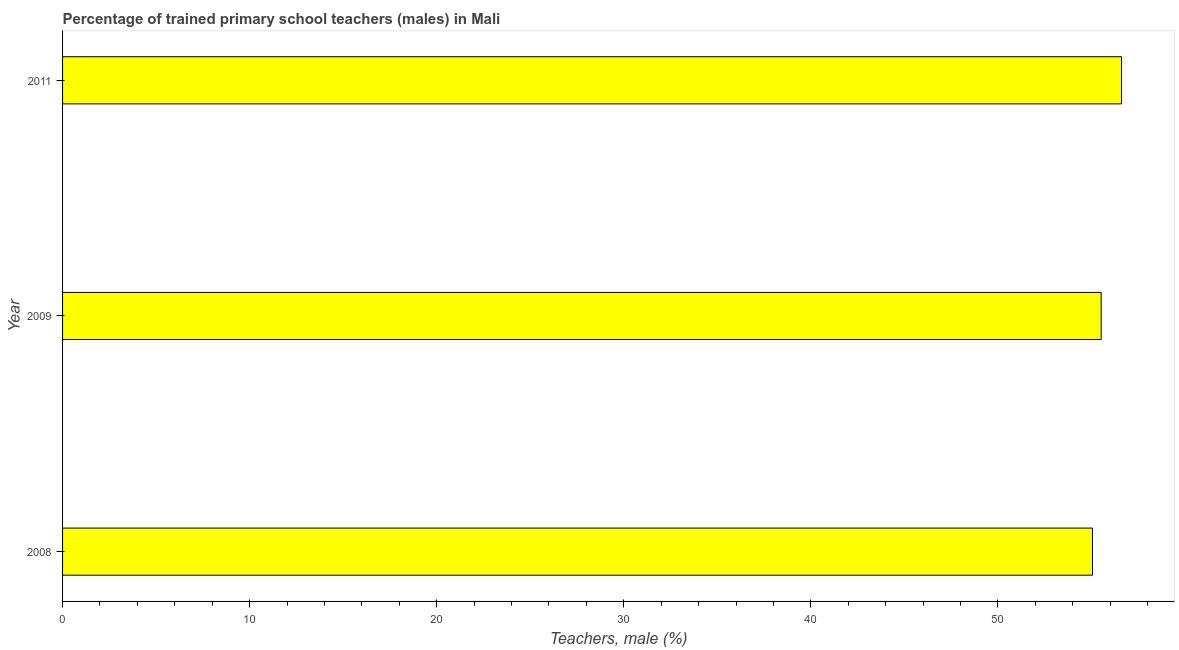Does the graph contain any zero values?
Keep it short and to the point. No. What is the title of the graph?
Ensure brevity in your answer.  Percentage of trained primary school teachers (males) in Mali. What is the label or title of the X-axis?
Provide a succinct answer. Teachers, male (%). What is the percentage of trained male teachers in 2011?
Your answer should be compact. 56.61. Across all years, what is the maximum percentage of trained male teachers?
Ensure brevity in your answer.  56.61. Across all years, what is the minimum percentage of trained male teachers?
Your response must be concise. 55.05. In which year was the percentage of trained male teachers maximum?
Give a very brief answer. 2011. In which year was the percentage of trained male teachers minimum?
Your answer should be very brief. 2008. What is the sum of the percentage of trained male teachers?
Ensure brevity in your answer.  167.18. What is the difference between the percentage of trained male teachers in 2008 and 2011?
Give a very brief answer. -1.55. What is the average percentage of trained male teachers per year?
Your answer should be very brief. 55.73. What is the median percentage of trained male teachers?
Ensure brevity in your answer.  55.52. In how many years, is the percentage of trained male teachers greater than 6 %?
Your answer should be compact. 3. Do a majority of the years between 2009 and 2011 (inclusive) have percentage of trained male teachers greater than 6 %?
Give a very brief answer. Yes. What is the ratio of the percentage of trained male teachers in 2008 to that in 2011?
Provide a short and direct response. 0.97. Is the percentage of trained male teachers in 2008 less than that in 2009?
Your answer should be compact. Yes. Is the difference between the percentage of trained male teachers in 2008 and 2009 greater than the difference between any two years?
Provide a short and direct response. No. What is the difference between the highest and the second highest percentage of trained male teachers?
Provide a short and direct response. 1.09. What is the difference between the highest and the lowest percentage of trained male teachers?
Your response must be concise. 1.55. In how many years, is the percentage of trained male teachers greater than the average percentage of trained male teachers taken over all years?
Your response must be concise. 1. How many bars are there?
Provide a short and direct response. 3. Are the values on the major ticks of X-axis written in scientific E-notation?
Your response must be concise. No. What is the Teachers, male (%) of 2008?
Provide a succinct answer. 55.05. What is the Teachers, male (%) of 2009?
Provide a short and direct response. 55.52. What is the Teachers, male (%) in 2011?
Provide a succinct answer. 56.61. What is the difference between the Teachers, male (%) in 2008 and 2009?
Make the answer very short. -0.46. What is the difference between the Teachers, male (%) in 2008 and 2011?
Your answer should be very brief. -1.55. What is the difference between the Teachers, male (%) in 2009 and 2011?
Offer a terse response. -1.09. What is the ratio of the Teachers, male (%) in 2008 to that in 2011?
Your response must be concise. 0.97. 